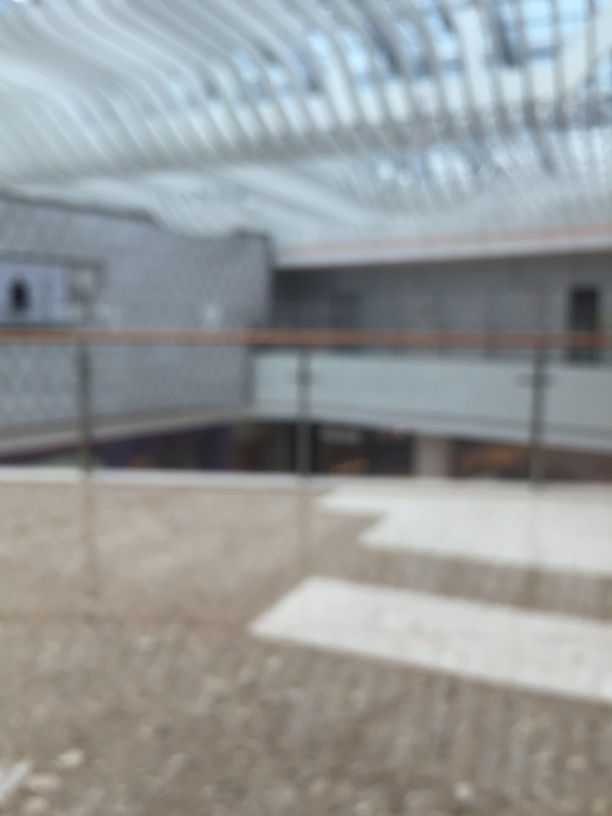Can you describe the architectural style or elements visible in this image, despite its blurriness? While the blurriness of this image makes it challenging to identify specific architectural details, the visible structural elements such as the trusses and the curvilinear form of the roof suggest a modern architectural style with an emphasis on open spaces and perhaps a large span, which is often seen in public buildings or transit centers. 